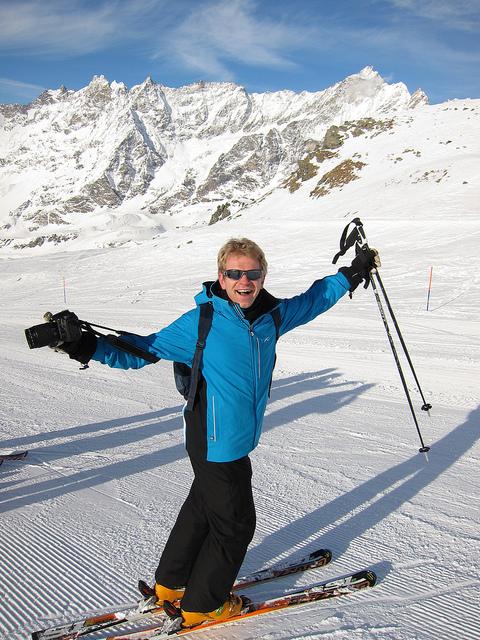Is the man alone on the hill?
Quick response, please. No. Is there snow?
Answer briefly. Yes. What color is the jacket of the person in this photograph?
Be succinct. Blue. 